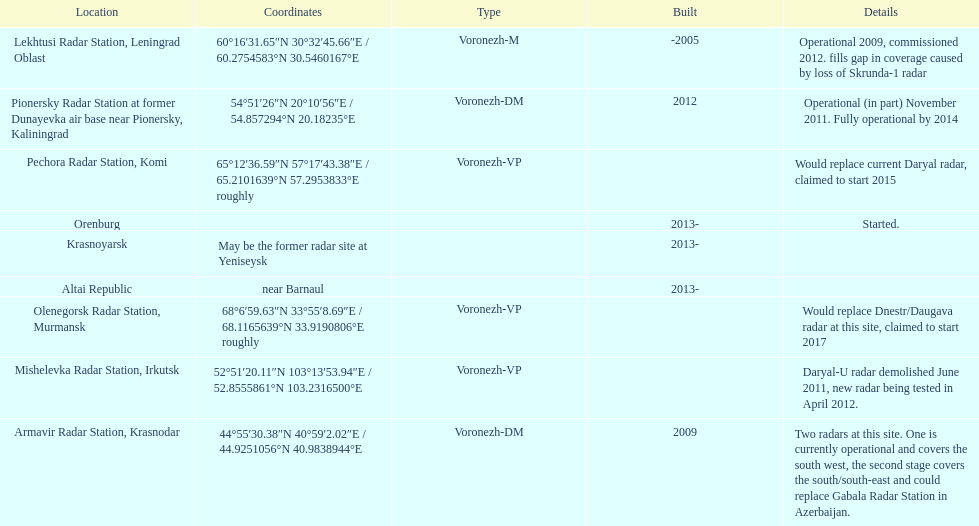How long did it take the pionersky radar station to go from partially operational to fully operational? 3 years. Could you parse the entire table as a dict? {'header': ['Location', 'Coordinates', 'Type', 'Built', 'Details'], 'rows': [['Lekhtusi Radar Station, Leningrad Oblast', '60°16′31.65″N 30°32′45.66″E\ufeff / \ufeff60.2754583°N 30.5460167°E', 'Voronezh-M', '-2005', 'Operational 2009, commissioned 2012. fills gap in coverage caused by loss of Skrunda-1 radar'], ['Pionersky Radar Station at former Dunayevka air base near Pionersky, Kaliningrad', '54°51′26″N 20°10′56″E\ufeff / \ufeff54.857294°N 20.18235°E', 'Voronezh-DM', '2012', 'Operational (in part) November 2011. Fully operational by 2014'], ['Pechora Radar Station, Komi', '65°12′36.59″N 57°17′43.38″E\ufeff / \ufeff65.2101639°N 57.2953833°E roughly', 'Voronezh-VP', '', 'Would replace current Daryal radar, claimed to start 2015'], ['Orenburg', '', '', '2013-', 'Started.'], ['Krasnoyarsk', 'May be the former radar site at Yeniseysk', '', '2013-', ''], ['Altai Republic', 'near Barnaul', '', '2013-', ''], ['Olenegorsk Radar Station, Murmansk', '68°6′59.63″N 33°55′8.69″E\ufeff / \ufeff68.1165639°N 33.9190806°E roughly', 'Voronezh-VP', '', 'Would replace Dnestr/Daugava radar at this site, claimed to start 2017'], ['Mishelevka Radar Station, Irkutsk', '52°51′20.11″N 103°13′53.94″E\ufeff / \ufeff52.8555861°N 103.2316500°E', 'Voronezh-VP', '', 'Daryal-U radar demolished June 2011, new radar being tested in April 2012.'], ['Armavir Radar Station, Krasnodar', '44°55′30.38″N 40°59′2.02″E\ufeff / \ufeff44.9251056°N 40.9838944°E', 'Voronezh-DM', '2009', 'Two radars at this site. One is currently operational and covers the south west, the second stage covers the south/south-east and could replace Gabala Radar Station in Azerbaijan.']]} 